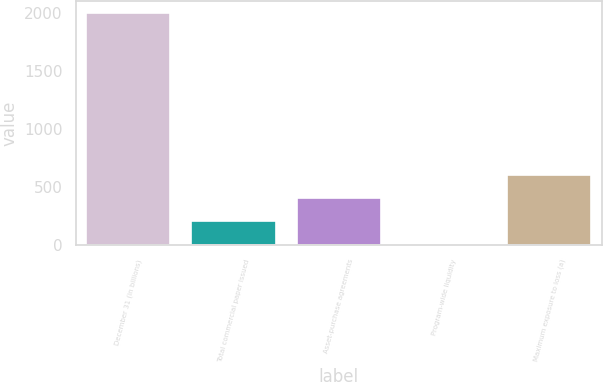Convert chart. <chart><loc_0><loc_0><loc_500><loc_500><bar_chart><fcel>December 31 (in billions)<fcel>Total commercial paper issued<fcel>Asset-purchase agreements<fcel>Program-wide liquidity<fcel>Maximum exposure to loss (a)<nl><fcel>2005<fcel>205<fcel>405<fcel>5<fcel>605<nl></chart> 